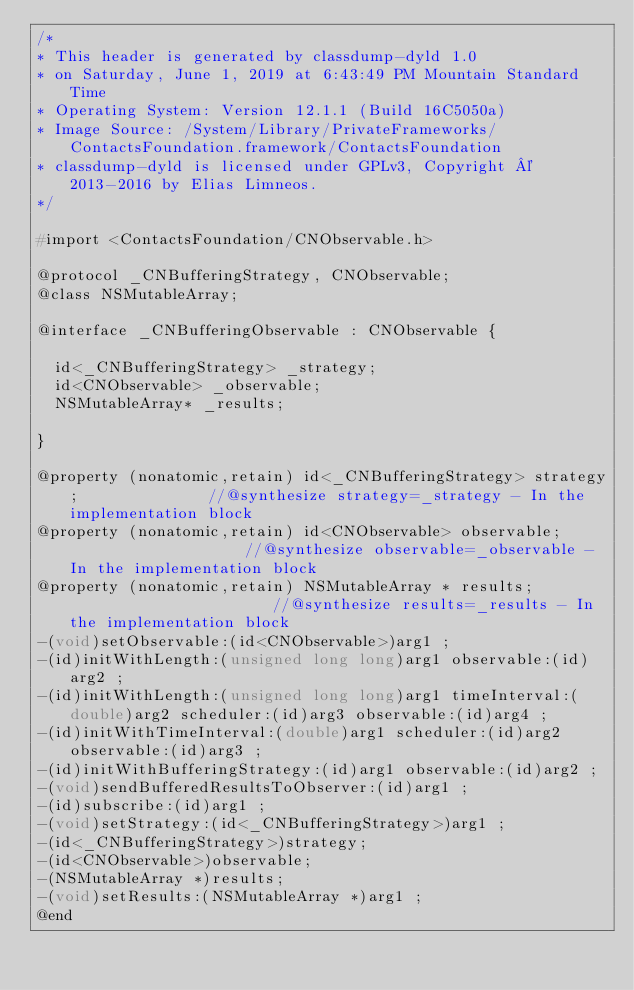<code> <loc_0><loc_0><loc_500><loc_500><_C_>/*
* This header is generated by classdump-dyld 1.0
* on Saturday, June 1, 2019 at 6:43:49 PM Mountain Standard Time
* Operating System: Version 12.1.1 (Build 16C5050a)
* Image Source: /System/Library/PrivateFrameworks/ContactsFoundation.framework/ContactsFoundation
* classdump-dyld is licensed under GPLv3, Copyright © 2013-2016 by Elias Limneos.
*/

#import <ContactsFoundation/CNObservable.h>

@protocol _CNBufferingStrategy, CNObservable;
@class NSMutableArray;

@interface _CNBufferingObservable : CNObservable {

	id<_CNBufferingStrategy> _strategy;
	id<CNObservable> _observable;
	NSMutableArray* _results;

}

@property (nonatomic,retain) id<_CNBufferingStrategy> strategy;              //@synthesize strategy=_strategy - In the implementation block
@property (nonatomic,retain) id<CNObservable> observable;                    //@synthesize observable=_observable - In the implementation block
@property (nonatomic,retain) NSMutableArray * results;                       //@synthesize results=_results - In the implementation block
-(void)setObservable:(id<CNObservable>)arg1 ;
-(id)initWithLength:(unsigned long long)arg1 observable:(id)arg2 ;
-(id)initWithLength:(unsigned long long)arg1 timeInterval:(double)arg2 scheduler:(id)arg3 observable:(id)arg4 ;
-(id)initWithTimeInterval:(double)arg1 scheduler:(id)arg2 observable:(id)arg3 ;
-(id)initWithBufferingStrategy:(id)arg1 observable:(id)arg2 ;
-(void)sendBufferedResultsToObserver:(id)arg1 ;
-(id)subscribe:(id)arg1 ;
-(void)setStrategy:(id<_CNBufferingStrategy>)arg1 ;
-(id<_CNBufferingStrategy>)strategy;
-(id<CNObservable>)observable;
-(NSMutableArray *)results;
-(void)setResults:(NSMutableArray *)arg1 ;
@end

</code> 